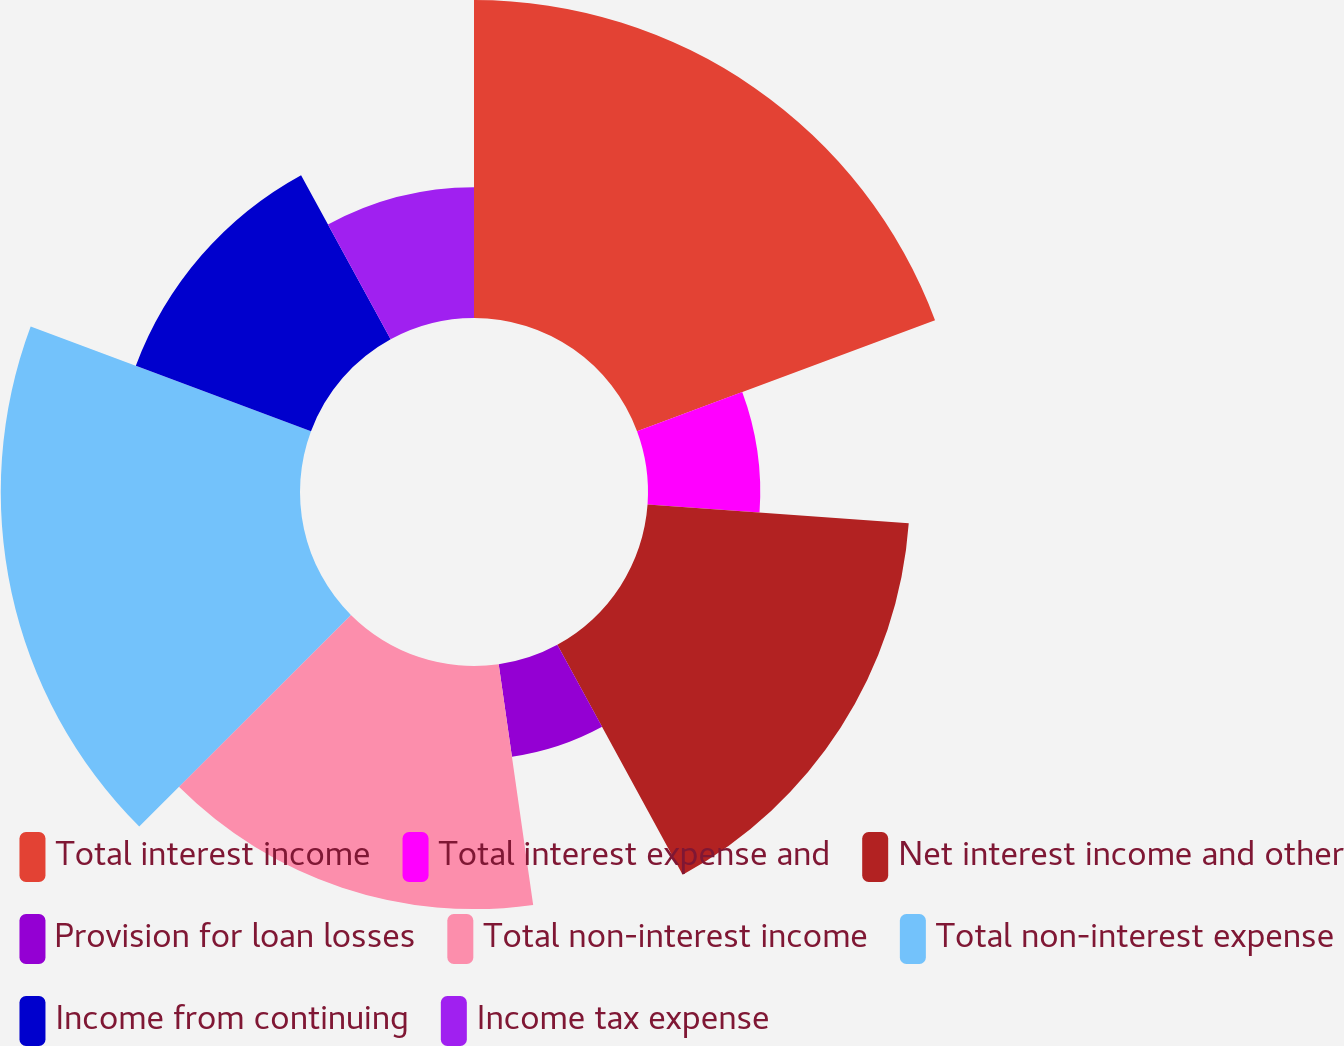<chart> <loc_0><loc_0><loc_500><loc_500><pie_chart><fcel>Total interest income<fcel>Total interest expense and<fcel>Net interest income and other<fcel>Provision for loan losses<fcel>Total non-interest income<fcel>Total non-interest expense<fcel>Income from continuing<fcel>Income tax expense<nl><fcel>19.32%<fcel>6.82%<fcel>15.91%<fcel>5.68%<fcel>14.77%<fcel>18.18%<fcel>11.36%<fcel>7.95%<nl></chart> 